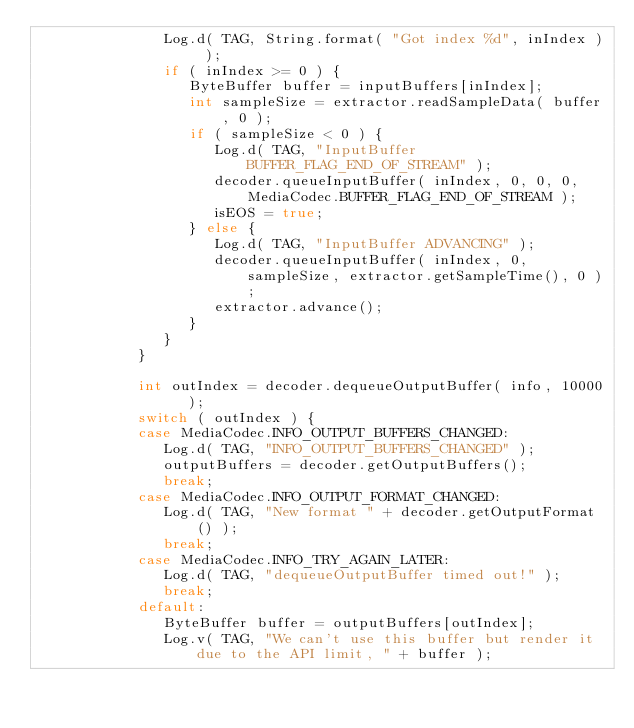<code> <loc_0><loc_0><loc_500><loc_500><_Java_>               Log.d( TAG, String.format( "Got index %d", inIndex ) );
               if ( inIndex >= 0 ) {
                  ByteBuffer buffer = inputBuffers[inIndex];
                  int sampleSize = extractor.readSampleData( buffer, 0 );
                  if ( sampleSize < 0 ) {
                     Log.d( TAG, "InputBuffer BUFFER_FLAG_END_OF_STREAM" );
                     decoder.queueInputBuffer( inIndex, 0, 0, 0, MediaCodec.BUFFER_FLAG_END_OF_STREAM );
                     isEOS = true;
                  } else {
                     Log.d( TAG, "InputBuffer ADVANCING" );
                     decoder.queueInputBuffer( inIndex, 0, sampleSize, extractor.getSampleTime(), 0 );
                     extractor.advance();
                  }
               }
            }

            int outIndex = decoder.dequeueOutputBuffer( info, 10000  );
            switch ( outIndex ) {
            case MediaCodec.INFO_OUTPUT_BUFFERS_CHANGED:
               Log.d( TAG, "INFO_OUTPUT_BUFFERS_CHANGED" );
               outputBuffers = decoder.getOutputBuffers();
               break;
            case MediaCodec.INFO_OUTPUT_FORMAT_CHANGED:
               Log.d( TAG, "New format " + decoder.getOutputFormat() );
               break;
            case MediaCodec.INFO_TRY_AGAIN_LATER:
               Log.d( TAG, "dequeueOutputBuffer timed out!" );
               break;
            default:
               ByteBuffer buffer = outputBuffers[outIndex];
               Log.v( TAG, "We can't use this buffer but render it due to the API limit, " + buffer );
</code> 